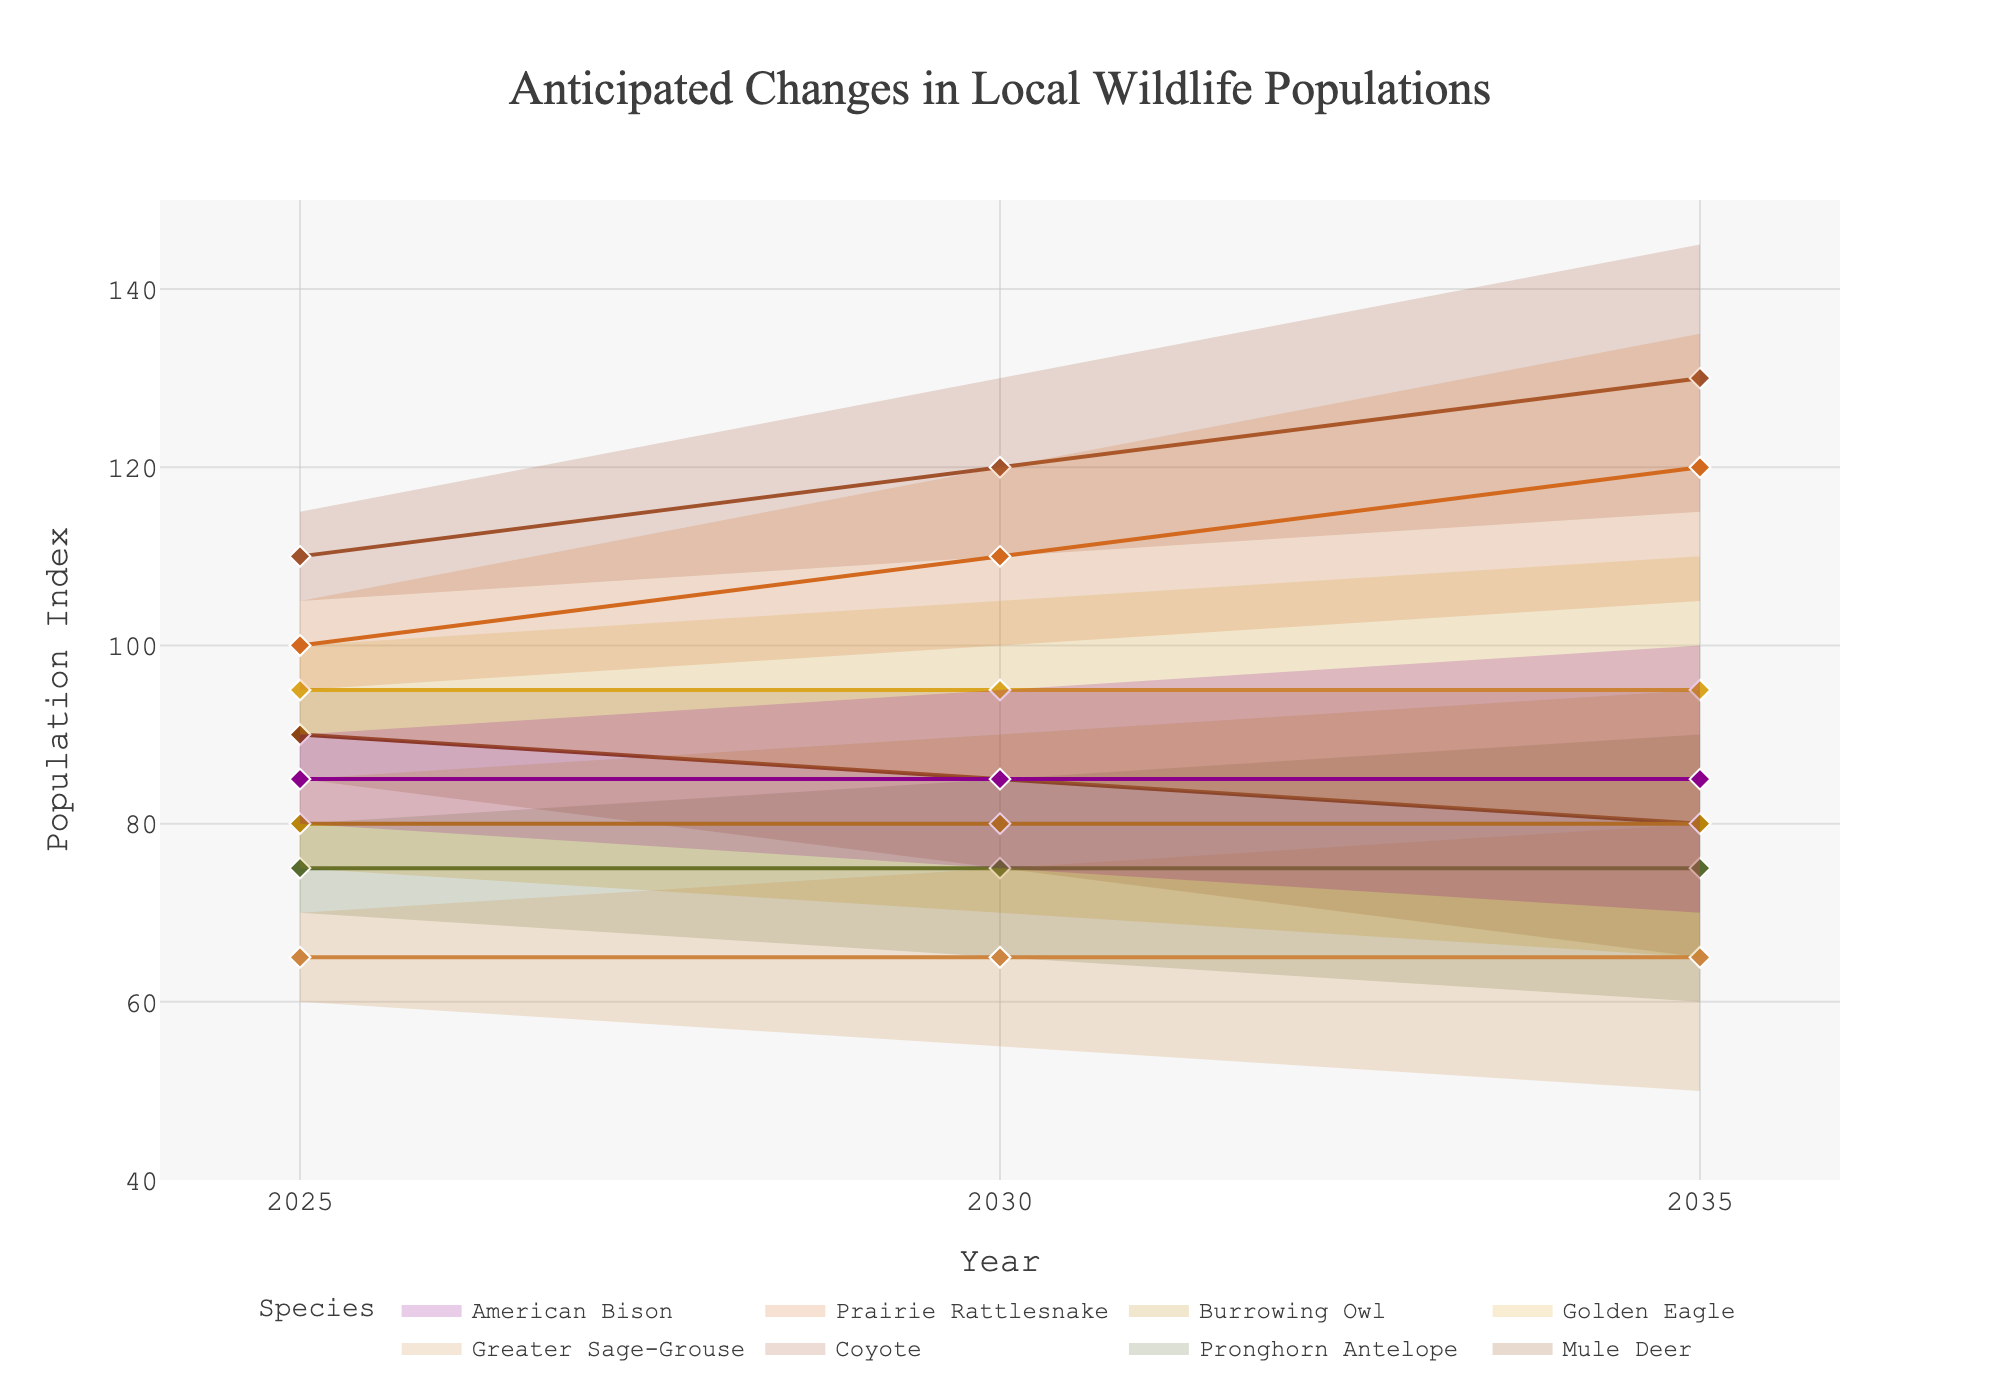What is the title of the figure? The title is located at the top of the figure and reads "Anticipated Changes in Local Wildlife Populations."
Answer: Anticipated Changes in Local Wildlife Populations Which species have a predicted population increase in 2035 compared to 2025 in the high scenario? Comparing population indices for 2035 and 2025 in the high scenario for each species, Coyotes have an increase from 115 to 145, Greater Sage-Grouse from 70 to 80, Prairie Rattlesnake from 105 to 135, and American Bison from 90 to 100.
Answer: Coyote, Greater Sage-Grouse, Prairie Rattlesnake, American Bison What is the average population index for Golden Eagle across the three years in the mid scenario? The mid scenario population indices for Golden Eagle in 2025, 2030, and 2035 are 95, 95, and 95 respectively. The average is calculated as (95 + 95 + 95) / 3.
Answer: 95 Which species shows the most significant population decrease in the low scenario from 2025 to 2035? Comparing the low scenario population indices from 2025 to 2035, Mule Deer shows the largest decrease from 85 to 65, which is a decrease of 20.
Answer: Mule Deer How does the population index for Pronghorn Antelope in the high scenario change between 2025 and 2030? The high scenario population index for Pronghorn Antelope in 2025 is 80, and in 2030 it is 85. The change is 85 - 80 = 5.
Answer: Increases by 5 What is the range of the population index for Burrowing Owl in 2030 across all scenarios? In 2030, the low, mid, and high scenario population indices for Burrowing Owl are 70, 80, and 90 respectively. The range is calculated as 90 - 70.
Answer: 20 Which species has the flattest (least variable) mid-scenario prediction from 2025 to 2035? The mid-scenario predictions can be observed across the years for each species. Golden Eagle maintains a constant population index of 95, showing no variability.
Answer: Golden Eagle Between Coyote and Prairie Rattlesnake, which species is predicted to have a higher population index in 2030 in the mid scenario? In the mid scenario for 2030, the population index for Coyote is 120, and for Prairie Rattlesnake, it is 110.
Answer: Coyote 